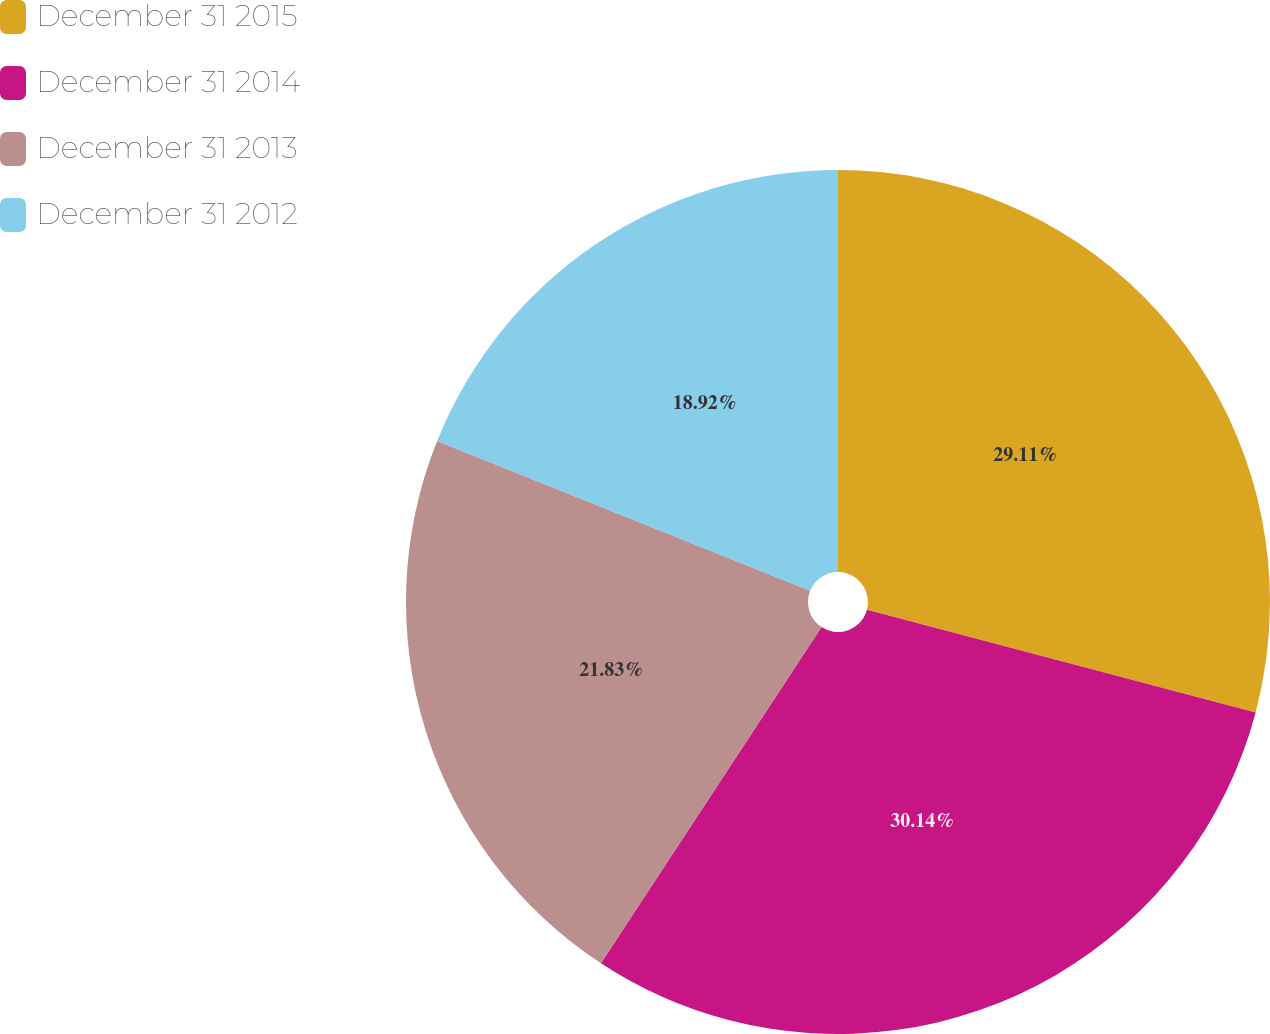<chart> <loc_0><loc_0><loc_500><loc_500><pie_chart><fcel>December 31 2015<fcel>December 31 2014<fcel>December 31 2013<fcel>December 31 2012<nl><fcel>29.11%<fcel>30.13%<fcel>21.83%<fcel>18.92%<nl></chart> 